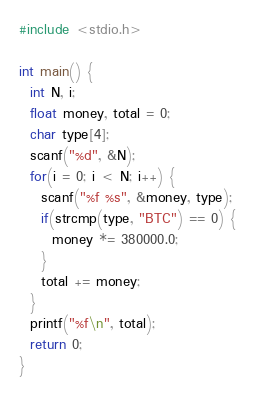Convert code to text. <code><loc_0><loc_0><loc_500><loc_500><_C_>#include <stdio.h>

int main() {
  int N, i;
  float money, total = 0;
  char type[4];
  scanf("%d", &N);
  for(i = 0; i < N; i++) {
    scanf("%f %s", &money, type);
    if(strcmp(type, "BTC") == 0) {
      money *= 380000.0;
    }
    total += money;
  }
  printf("%f\n", total);
  return 0;
}
</code> 